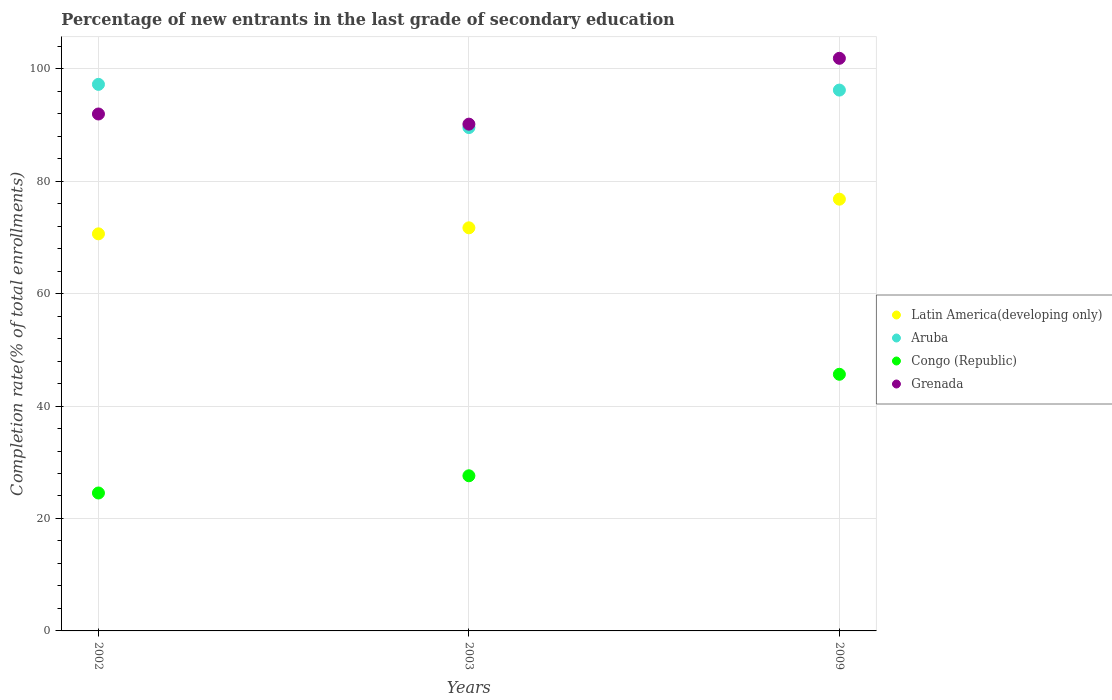What is the percentage of new entrants in Congo (Republic) in 2003?
Provide a short and direct response. 27.59. Across all years, what is the maximum percentage of new entrants in Congo (Republic)?
Keep it short and to the point. 45.65. Across all years, what is the minimum percentage of new entrants in Grenada?
Provide a short and direct response. 90.13. In which year was the percentage of new entrants in Aruba maximum?
Provide a short and direct response. 2002. What is the total percentage of new entrants in Latin America(developing only) in the graph?
Your response must be concise. 219.11. What is the difference between the percentage of new entrants in Latin America(developing only) in 2002 and that in 2003?
Offer a very short reply. -1.07. What is the difference between the percentage of new entrants in Aruba in 2003 and the percentage of new entrants in Congo (Republic) in 2009?
Provide a short and direct response. 43.88. What is the average percentage of new entrants in Grenada per year?
Your answer should be compact. 94.64. In the year 2009, what is the difference between the percentage of new entrants in Grenada and percentage of new entrants in Congo (Republic)?
Provide a succinct answer. 56.2. What is the ratio of the percentage of new entrants in Latin America(developing only) in 2003 to that in 2009?
Ensure brevity in your answer.  0.93. Is the difference between the percentage of new entrants in Grenada in 2002 and 2009 greater than the difference between the percentage of new entrants in Congo (Republic) in 2002 and 2009?
Ensure brevity in your answer.  Yes. What is the difference between the highest and the second highest percentage of new entrants in Aruba?
Offer a terse response. 1.02. What is the difference between the highest and the lowest percentage of new entrants in Grenada?
Make the answer very short. 11.71. Is the percentage of new entrants in Latin America(developing only) strictly greater than the percentage of new entrants in Aruba over the years?
Your response must be concise. No. How many dotlines are there?
Ensure brevity in your answer.  4. How many years are there in the graph?
Your answer should be very brief. 3. Are the values on the major ticks of Y-axis written in scientific E-notation?
Provide a short and direct response. No. Does the graph contain any zero values?
Your answer should be compact. No. Where does the legend appear in the graph?
Keep it short and to the point. Center right. How many legend labels are there?
Offer a terse response. 4. How are the legend labels stacked?
Keep it short and to the point. Vertical. What is the title of the graph?
Make the answer very short. Percentage of new entrants in the last grade of secondary education. What is the label or title of the X-axis?
Provide a short and direct response. Years. What is the label or title of the Y-axis?
Make the answer very short. Completion rate(% of total enrollments). What is the Completion rate(% of total enrollments) of Latin America(developing only) in 2002?
Keep it short and to the point. 70.63. What is the Completion rate(% of total enrollments) of Aruba in 2002?
Provide a short and direct response. 97.21. What is the Completion rate(% of total enrollments) of Congo (Republic) in 2002?
Ensure brevity in your answer.  24.53. What is the Completion rate(% of total enrollments) of Grenada in 2002?
Your answer should be very brief. 91.94. What is the Completion rate(% of total enrollments) of Latin America(developing only) in 2003?
Give a very brief answer. 71.7. What is the Completion rate(% of total enrollments) in Aruba in 2003?
Ensure brevity in your answer.  89.53. What is the Completion rate(% of total enrollments) in Congo (Republic) in 2003?
Provide a short and direct response. 27.59. What is the Completion rate(% of total enrollments) of Grenada in 2003?
Your response must be concise. 90.13. What is the Completion rate(% of total enrollments) in Latin America(developing only) in 2009?
Your answer should be very brief. 76.79. What is the Completion rate(% of total enrollments) in Aruba in 2009?
Provide a short and direct response. 96.19. What is the Completion rate(% of total enrollments) in Congo (Republic) in 2009?
Your answer should be compact. 45.65. What is the Completion rate(% of total enrollments) in Grenada in 2009?
Keep it short and to the point. 101.84. Across all years, what is the maximum Completion rate(% of total enrollments) in Latin America(developing only)?
Give a very brief answer. 76.79. Across all years, what is the maximum Completion rate(% of total enrollments) in Aruba?
Ensure brevity in your answer.  97.21. Across all years, what is the maximum Completion rate(% of total enrollments) in Congo (Republic)?
Ensure brevity in your answer.  45.65. Across all years, what is the maximum Completion rate(% of total enrollments) of Grenada?
Ensure brevity in your answer.  101.84. Across all years, what is the minimum Completion rate(% of total enrollments) of Latin America(developing only)?
Your answer should be compact. 70.63. Across all years, what is the minimum Completion rate(% of total enrollments) in Aruba?
Keep it short and to the point. 89.53. Across all years, what is the minimum Completion rate(% of total enrollments) in Congo (Republic)?
Keep it short and to the point. 24.53. Across all years, what is the minimum Completion rate(% of total enrollments) of Grenada?
Offer a very short reply. 90.13. What is the total Completion rate(% of total enrollments) of Latin America(developing only) in the graph?
Offer a terse response. 219.11. What is the total Completion rate(% of total enrollments) in Aruba in the graph?
Make the answer very short. 282.93. What is the total Completion rate(% of total enrollments) of Congo (Republic) in the graph?
Make the answer very short. 97.77. What is the total Completion rate(% of total enrollments) in Grenada in the graph?
Make the answer very short. 283.92. What is the difference between the Completion rate(% of total enrollments) in Latin America(developing only) in 2002 and that in 2003?
Keep it short and to the point. -1.07. What is the difference between the Completion rate(% of total enrollments) in Aruba in 2002 and that in 2003?
Make the answer very short. 7.68. What is the difference between the Completion rate(% of total enrollments) in Congo (Republic) in 2002 and that in 2003?
Offer a terse response. -3.06. What is the difference between the Completion rate(% of total enrollments) of Grenada in 2002 and that in 2003?
Your answer should be compact. 1.81. What is the difference between the Completion rate(% of total enrollments) in Latin America(developing only) in 2002 and that in 2009?
Provide a short and direct response. -6.16. What is the difference between the Completion rate(% of total enrollments) in Aruba in 2002 and that in 2009?
Offer a terse response. 1.02. What is the difference between the Completion rate(% of total enrollments) of Congo (Republic) in 2002 and that in 2009?
Your answer should be compact. -21.11. What is the difference between the Completion rate(% of total enrollments) in Grenada in 2002 and that in 2009?
Give a very brief answer. -9.9. What is the difference between the Completion rate(% of total enrollments) in Latin America(developing only) in 2003 and that in 2009?
Give a very brief answer. -5.09. What is the difference between the Completion rate(% of total enrollments) of Aruba in 2003 and that in 2009?
Provide a short and direct response. -6.67. What is the difference between the Completion rate(% of total enrollments) of Congo (Republic) in 2003 and that in 2009?
Keep it short and to the point. -18.05. What is the difference between the Completion rate(% of total enrollments) of Grenada in 2003 and that in 2009?
Keep it short and to the point. -11.71. What is the difference between the Completion rate(% of total enrollments) of Latin America(developing only) in 2002 and the Completion rate(% of total enrollments) of Aruba in 2003?
Keep it short and to the point. -18.9. What is the difference between the Completion rate(% of total enrollments) in Latin America(developing only) in 2002 and the Completion rate(% of total enrollments) in Congo (Republic) in 2003?
Your answer should be very brief. 43.03. What is the difference between the Completion rate(% of total enrollments) in Latin America(developing only) in 2002 and the Completion rate(% of total enrollments) in Grenada in 2003?
Your answer should be compact. -19.51. What is the difference between the Completion rate(% of total enrollments) in Aruba in 2002 and the Completion rate(% of total enrollments) in Congo (Republic) in 2003?
Provide a succinct answer. 69.62. What is the difference between the Completion rate(% of total enrollments) of Aruba in 2002 and the Completion rate(% of total enrollments) of Grenada in 2003?
Your answer should be compact. 7.08. What is the difference between the Completion rate(% of total enrollments) in Congo (Republic) in 2002 and the Completion rate(% of total enrollments) in Grenada in 2003?
Provide a succinct answer. -65.6. What is the difference between the Completion rate(% of total enrollments) of Latin America(developing only) in 2002 and the Completion rate(% of total enrollments) of Aruba in 2009?
Offer a very short reply. -25.57. What is the difference between the Completion rate(% of total enrollments) in Latin America(developing only) in 2002 and the Completion rate(% of total enrollments) in Congo (Republic) in 2009?
Offer a terse response. 24.98. What is the difference between the Completion rate(% of total enrollments) in Latin America(developing only) in 2002 and the Completion rate(% of total enrollments) in Grenada in 2009?
Your answer should be very brief. -31.22. What is the difference between the Completion rate(% of total enrollments) of Aruba in 2002 and the Completion rate(% of total enrollments) of Congo (Republic) in 2009?
Your response must be concise. 51.56. What is the difference between the Completion rate(% of total enrollments) in Aruba in 2002 and the Completion rate(% of total enrollments) in Grenada in 2009?
Give a very brief answer. -4.63. What is the difference between the Completion rate(% of total enrollments) in Congo (Republic) in 2002 and the Completion rate(% of total enrollments) in Grenada in 2009?
Make the answer very short. -77.31. What is the difference between the Completion rate(% of total enrollments) in Latin America(developing only) in 2003 and the Completion rate(% of total enrollments) in Aruba in 2009?
Provide a succinct answer. -24.5. What is the difference between the Completion rate(% of total enrollments) of Latin America(developing only) in 2003 and the Completion rate(% of total enrollments) of Congo (Republic) in 2009?
Your response must be concise. 26.05. What is the difference between the Completion rate(% of total enrollments) of Latin America(developing only) in 2003 and the Completion rate(% of total enrollments) of Grenada in 2009?
Give a very brief answer. -30.15. What is the difference between the Completion rate(% of total enrollments) of Aruba in 2003 and the Completion rate(% of total enrollments) of Congo (Republic) in 2009?
Provide a short and direct response. 43.88. What is the difference between the Completion rate(% of total enrollments) in Aruba in 2003 and the Completion rate(% of total enrollments) in Grenada in 2009?
Make the answer very short. -12.32. What is the difference between the Completion rate(% of total enrollments) in Congo (Republic) in 2003 and the Completion rate(% of total enrollments) in Grenada in 2009?
Your response must be concise. -74.25. What is the average Completion rate(% of total enrollments) of Latin America(developing only) per year?
Provide a succinct answer. 73.04. What is the average Completion rate(% of total enrollments) of Aruba per year?
Keep it short and to the point. 94.31. What is the average Completion rate(% of total enrollments) in Congo (Republic) per year?
Your response must be concise. 32.59. What is the average Completion rate(% of total enrollments) of Grenada per year?
Give a very brief answer. 94.64. In the year 2002, what is the difference between the Completion rate(% of total enrollments) in Latin America(developing only) and Completion rate(% of total enrollments) in Aruba?
Provide a short and direct response. -26.58. In the year 2002, what is the difference between the Completion rate(% of total enrollments) in Latin America(developing only) and Completion rate(% of total enrollments) in Congo (Republic)?
Make the answer very short. 46.09. In the year 2002, what is the difference between the Completion rate(% of total enrollments) in Latin America(developing only) and Completion rate(% of total enrollments) in Grenada?
Your answer should be compact. -21.32. In the year 2002, what is the difference between the Completion rate(% of total enrollments) in Aruba and Completion rate(% of total enrollments) in Congo (Republic)?
Provide a short and direct response. 72.68. In the year 2002, what is the difference between the Completion rate(% of total enrollments) of Aruba and Completion rate(% of total enrollments) of Grenada?
Keep it short and to the point. 5.27. In the year 2002, what is the difference between the Completion rate(% of total enrollments) in Congo (Republic) and Completion rate(% of total enrollments) in Grenada?
Offer a very short reply. -67.41. In the year 2003, what is the difference between the Completion rate(% of total enrollments) of Latin America(developing only) and Completion rate(% of total enrollments) of Aruba?
Your response must be concise. -17.83. In the year 2003, what is the difference between the Completion rate(% of total enrollments) in Latin America(developing only) and Completion rate(% of total enrollments) in Congo (Republic)?
Your response must be concise. 44.1. In the year 2003, what is the difference between the Completion rate(% of total enrollments) of Latin America(developing only) and Completion rate(% of total enrollments) of Grenada?
Provide a succinct answer. -18.44. In the year 2003, what is the difference between the Completion rate(% of total enrollments) in Aruba and Completion rate(% of total enrollments) in Congo (Republic)?
Provide a succinct answer. 61.93. In the year 2003, what is the difference between the Completion rate(% of total enrollments) in Aruba and Completion rate(% of total enrollments) in Grenada?
Make the answer very short. -0.61. In the year 2003, what is the difference between the Completion rate(% of total enrollments) in Congo (Republic) and Completion rate(% of total enrollments) in Grenada?
Give a very brief answer. -62.54. In the year 2009, what is the difference between the Completion rate(% of total enrollments) in Latin America(developing only) and Completion rate(% of total enrollments) in Aruba?
Your answer should be compact. -19.4. In the year 2009, what is the difference between the Completion rate(% of total enrollments) in Latin America(developing only) and Completion rate(% of total enrollments) in Congo (Republic)?
Give a very brief answer. 31.14. In the year 2009, what is the difference between the Completion rate(% of total enrollments) in Latin America(developing only) and Completion rate(% of total enrollments) in Grenada?
Offer a terse response. -25.05. In the year 2009, what is the difference between the Completion rate(% of total enrollments) of Aruba and Completion rate(% of total enrollments) of Congo (Republic)?
Give a very brief answer. 50.55. In the year 2009, what is the difference between the Completion rate(% of total enrollments) of Aruba and Completion rate(% of total enrollments) of Grenada?
Provide a succinct answer. -5.65. In the year 2009, what is the difference between the Completion rate(% of total enrollments) of Congo (Republic) and Completion rate(% of total enrollments) of Grenada?
Make the answer very short. -56.2. What is the ratio of the Completion rate(% of total enrollments) in Latin America(developing only) in 2002 to that in 2003?
Ensure brevity in your answer.  0.99. What is the ratio of the Completion rate(% of total enrollments) of Aruba in 2002 to that in 2003?
Offer a terse response. 1.09. What is the ratio of the Completion rate(% of total enrollments) in Congo (Republic) in 2002 to that in 2003?
Your answer should be compact. 0.89. What is the ratio of the Completion rate(% of total enrollments) of Grenada in 2002 to that in 2003?
Your response must be concise. 1.02. What is the ratio of the Completion rate(% of total enrollments) of Latin America(developing only) in 2002 to that in 2009?
Your response must be concise. 0.92. What is the ratio of the Completion rate(% of total enrollments) of Aruba in 2002 to that in 2009?
Your answer should be compact. 1.01. What is the ratio of the Completion rate(% of total enrollments) in Congo (Republic) in 2002 to that in 2009?
Provide a short and direct response. 0.54. What is the ratio of the Completion rate(% of total enrollments) in Grenada in 2002 to that in 2009?
Your answer should be very brief. 0.9. What is the ratio of the Completion rate(% of total enrollments) of Latin America(developing only) in 2003 to that in 2009?
Make the answer very short. 0.93. What is the ratio of the Completion rate(% of total enrollments) in Aruba in 2003 to that in 2009?
Offer a terse response. 0.93. What is the ratio of the Completion rate(% of total enrollments) of Congo (Republic) in 2003 to that in 2009?
Your response must be concise. 0.6. What is the ratio of the Completion rate(% of total enrollments) of Grenada in 2003 to that in 2009?
Provide a short and direct response. 0.89. What is the difference between the highest and the second highest Completion rate(% of total enrollments) in Latin America(developing only)?
Make the answer very short. 5.09. What is the difference between the highest and the second highest Completion rate(% of total enrollments) in Aruba?
Your response must be concise. 1.02. What is the difference between the highest and the second highest Completion rate(% of total enrollments) in Congo (Republic)?
Your answer should be compact. 18.05. What is the difference between the highest and the second highest Completion rate(% of total enrollments) in Grenada?
Make the answer very short. 9.9. What is the difference between the highest and the lowest Completion rate(% of total enrollments) of Latin America(developing only)?
Ensure brevity in your answer.  6.16. What is the difference between the highest and the lowest Completion rate(% of total enrollments) in Aruba?
Your answer should be compact. 7.68. What is the difference between the highest and the lowest Completion rate(% of total enrollments) in Congo (Republic)?
Provide a short and direct response. 21.11. What is the difference between the highest and the lowest Completion rate(% of total enrollments) in Grenada?
Make the answer very short. 11.71. 